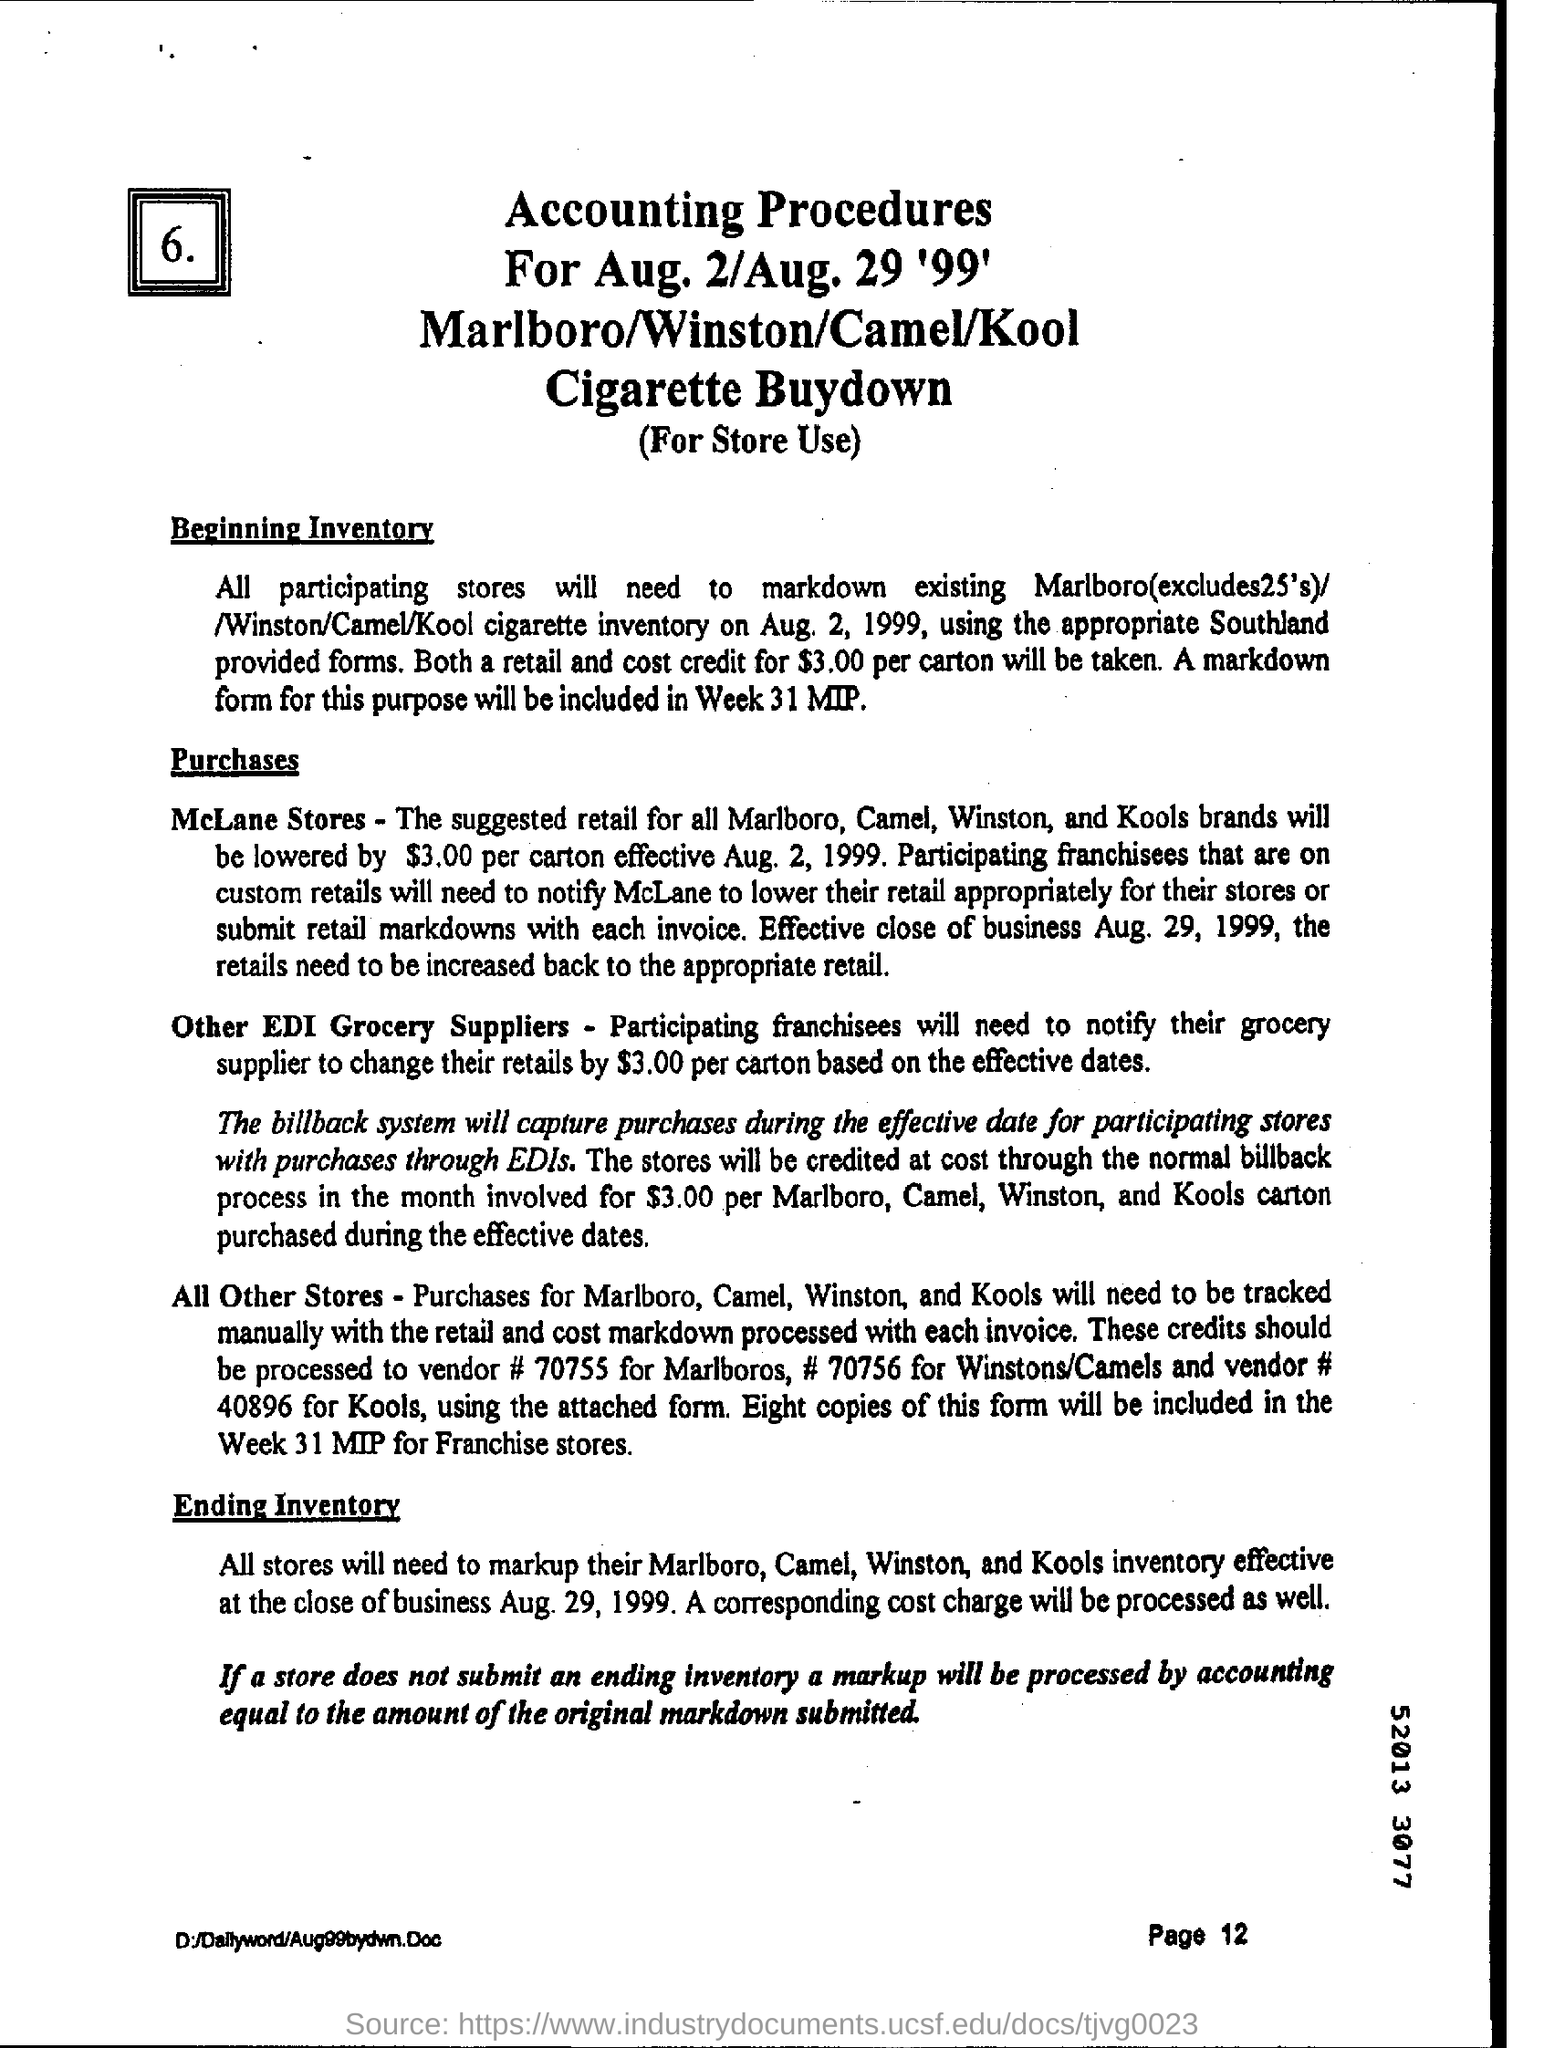What is the page number written on the bottom? The page number written at the bottom of the document is Page 12, which can be found at the bottom right corner, confirming that this is the twelfth page of the given material. 